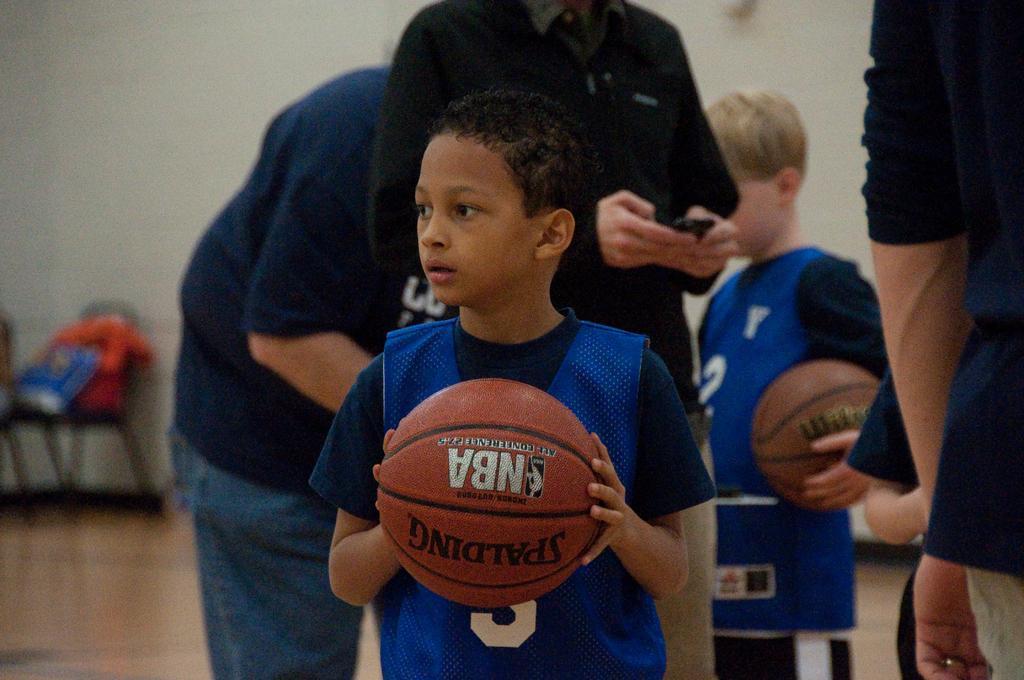Can you describe this image briefly? This is a wall. We can see chair on the floor. We can see boys holding balls in their hands and persons standing on the floor. 